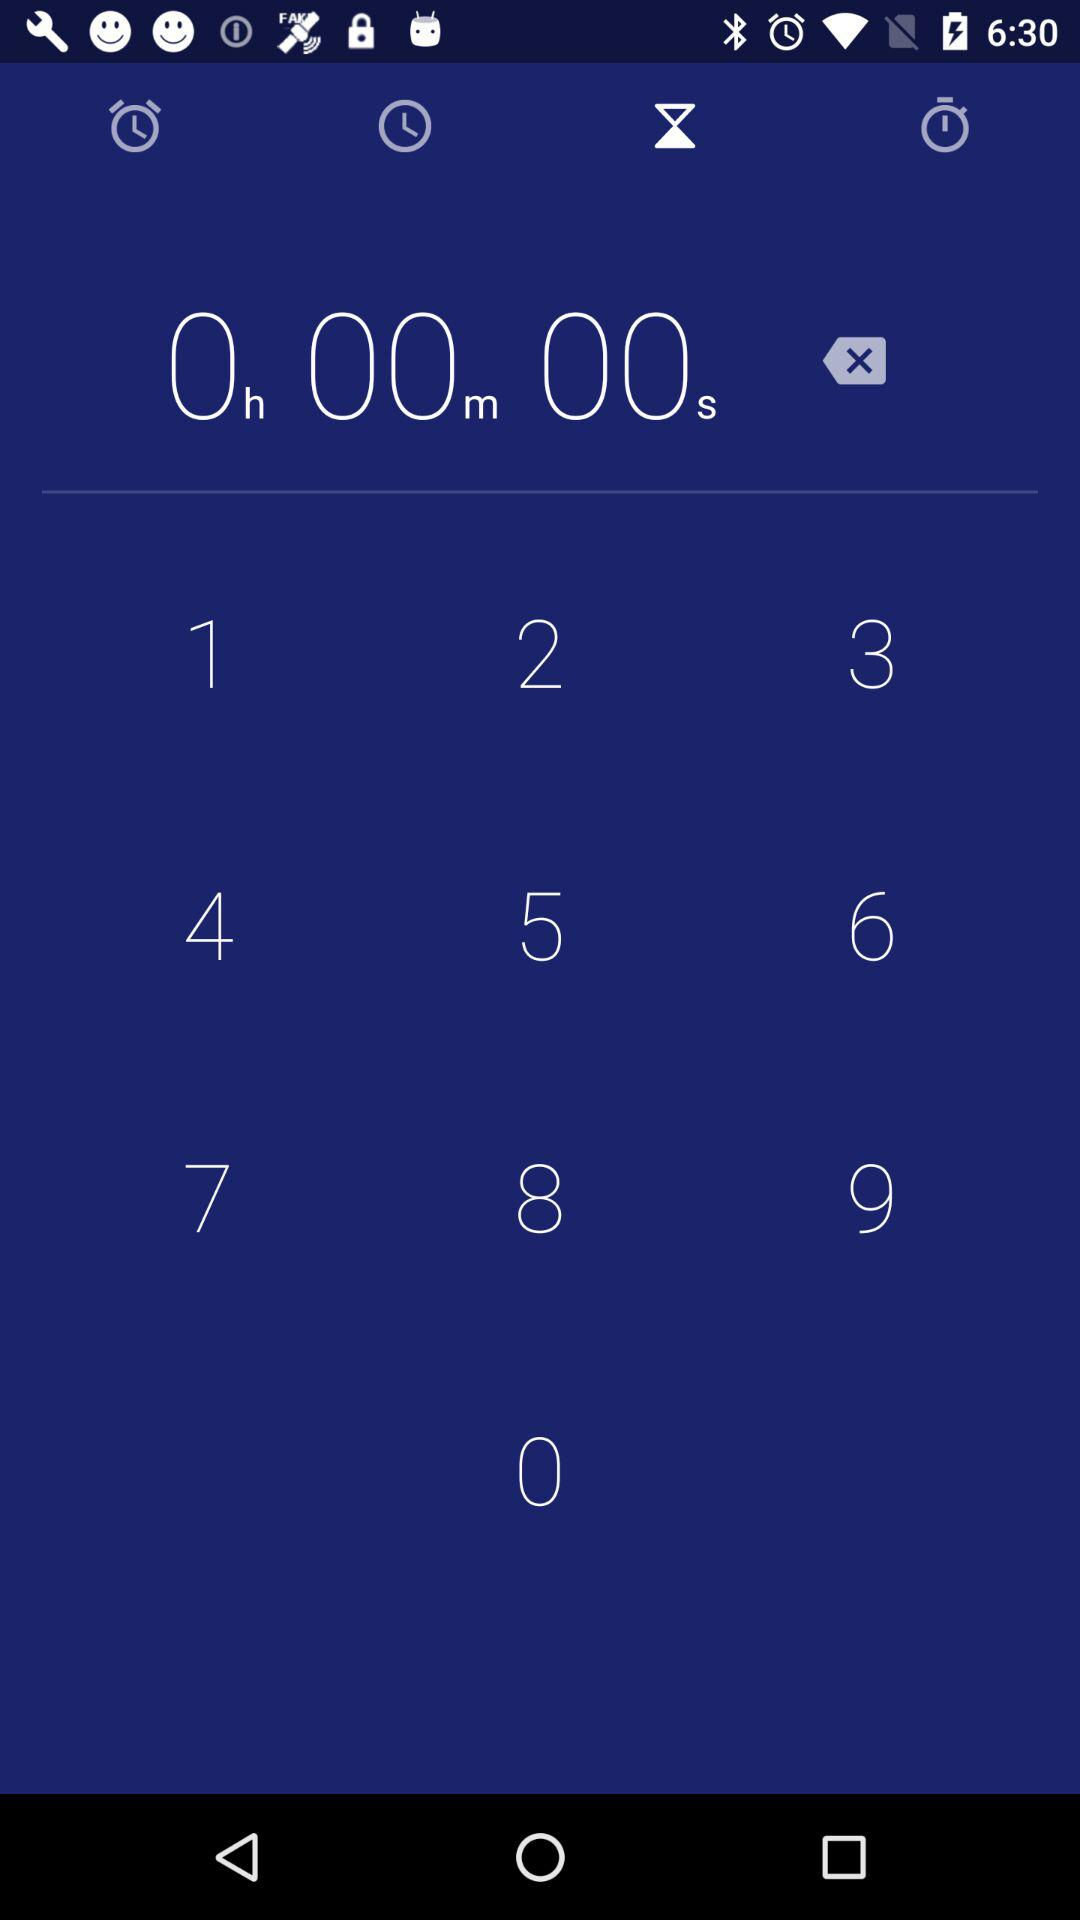What time is set on the timer? The time set on the timer is 0 hours 0 minutes 0 seconds. 